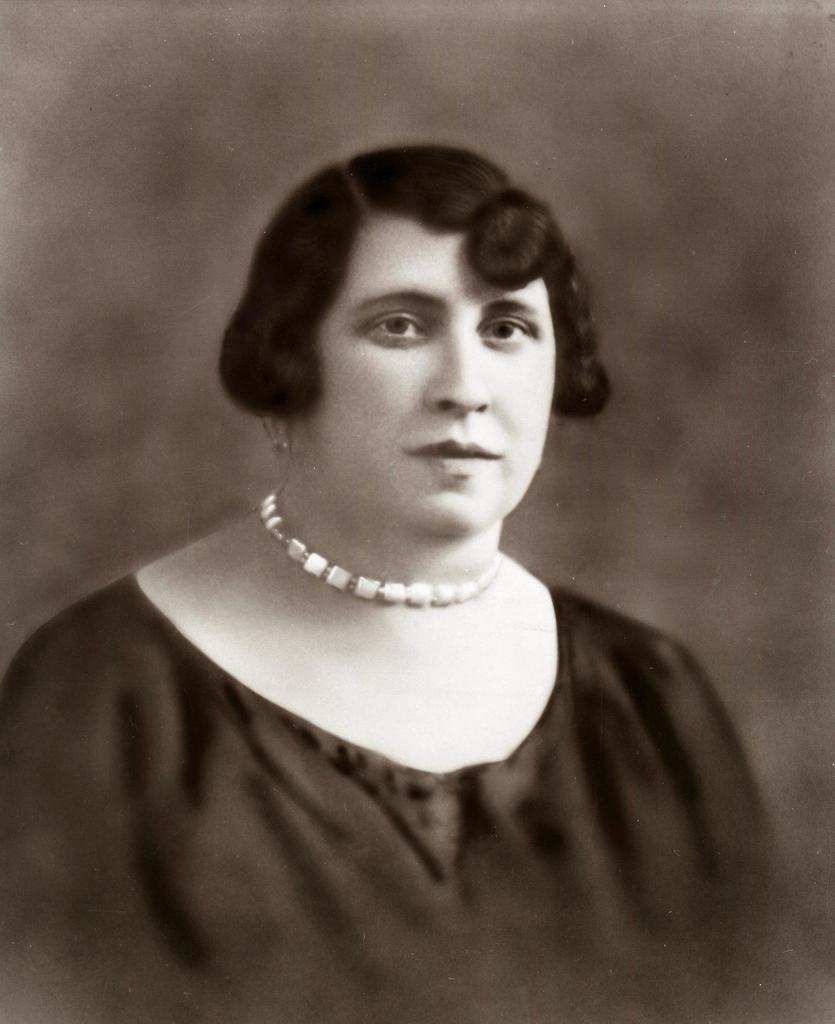Who is the main subject in the image? There is a lady in the image. What accessory is the lady wearing? The lady is wearing a necklace. Can you describe the background of the image? The background of the image is blurred. What color scheme is used in the image? The image is in black and white mode. What type of instrument is the lady playing in the image? There is no instrument present in the image, and the lady is not playing any instrument. 